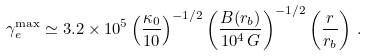Convert formula to latex. <formula><loc_0><loc_0><loc_500><loc_500>\gamma _ { e } ^ { \max } \simeq 3 . 2 \times 1 0 ^ { 5 } \left ( \frac { \kappa _ { 0 } } { 1 0 } \right ) ^ { - 1 / 2 } \left ( \frac { B ( r _ { b } ) } { 1 0 ^ { 4 } \, G } \right ) ^ { - 1 / 2 } \left ( \frac { r } { r _ { b } } \right ) \, .</formula> 